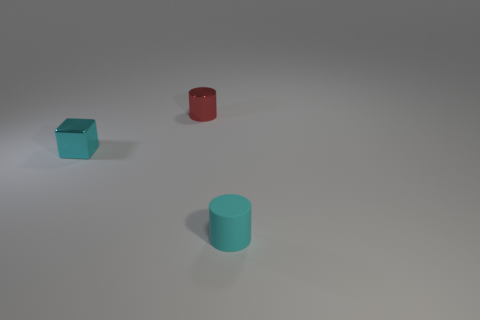Add 3 tiny brown cubes. How many objects exist? 6 Subtract all blocks. How many objects are left? 2 Subtract 1 cubes. How many cubes are left? 0 Subtract all cyan cylinders. Subtract all small cyan cylinders. How many objects are left? 1 Add 1 tiny cyan matte cylinders. How many tiny cyan matte cylinders are left? 2 Add 3 red cylinders. How many red cylinders exist? 4 Subtract 0 brown cubes. How many objects are left? 3 Subtract all blue blocks. Subtract all purple cylinders. How many blocks are left? 1 Subtract all blue spheres. How many blue blocks are left? 0 